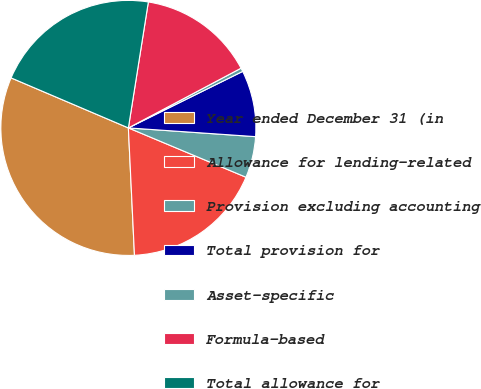Convert chart to OTSL. <chart><loc_0><loc_0><loc_500><loc_500><pie_chart><fcel>Year ended December 31 (in<fcel>Allowance for lending-related<fcel>Provision excluding accounting<fcel>Total provision for<fcel>Asset-specific<fcel>Formula-based<fcel>Total allowance for<nl><fcel>32.18%<fcel>17.92%<fcel>5.23%<fcel>8.4%<fcel>0.45%<fcel>14.74%<fcel>21.09%<nl></chart> 